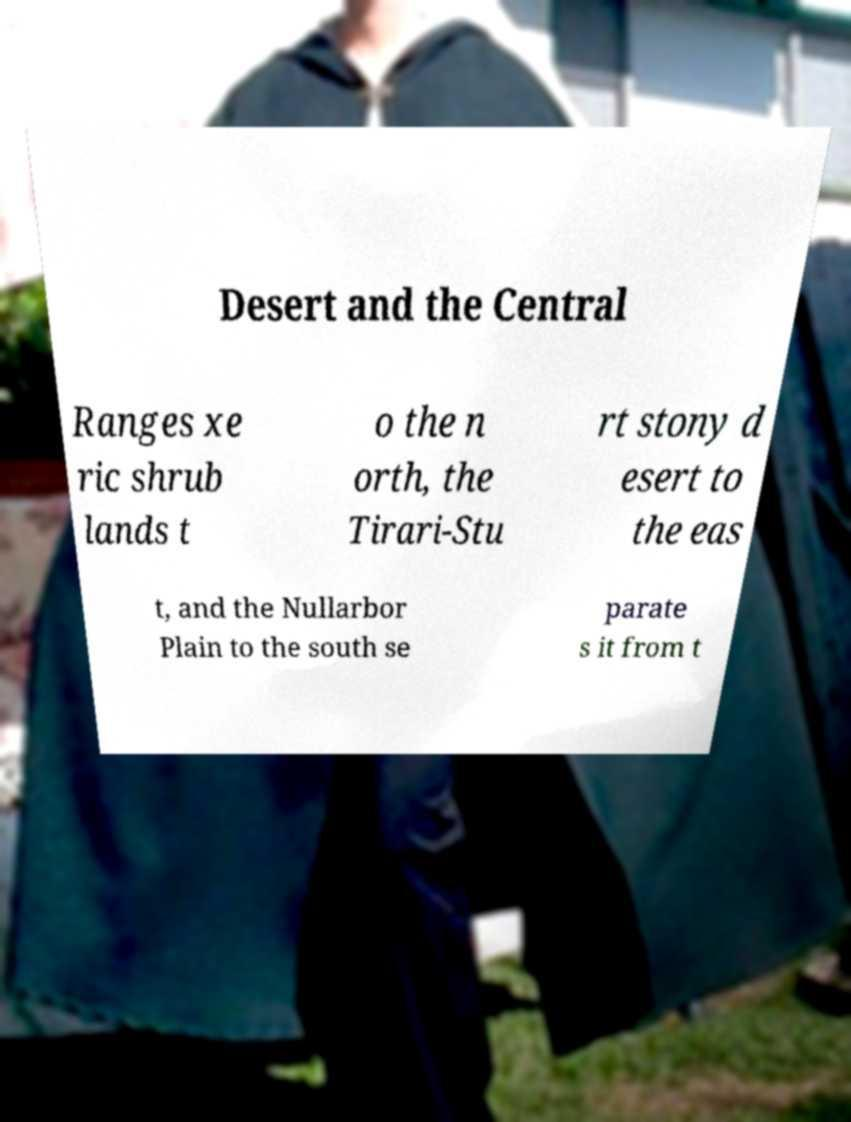I need the written content from this picture converted into text. Can you do that? Desert and the Central Ranges xe ric shrub lands t o the n orth, the Tirari-Stu rt stony d esert to the eas t, and the Nullarbor Plain to the south se parate s it from t 